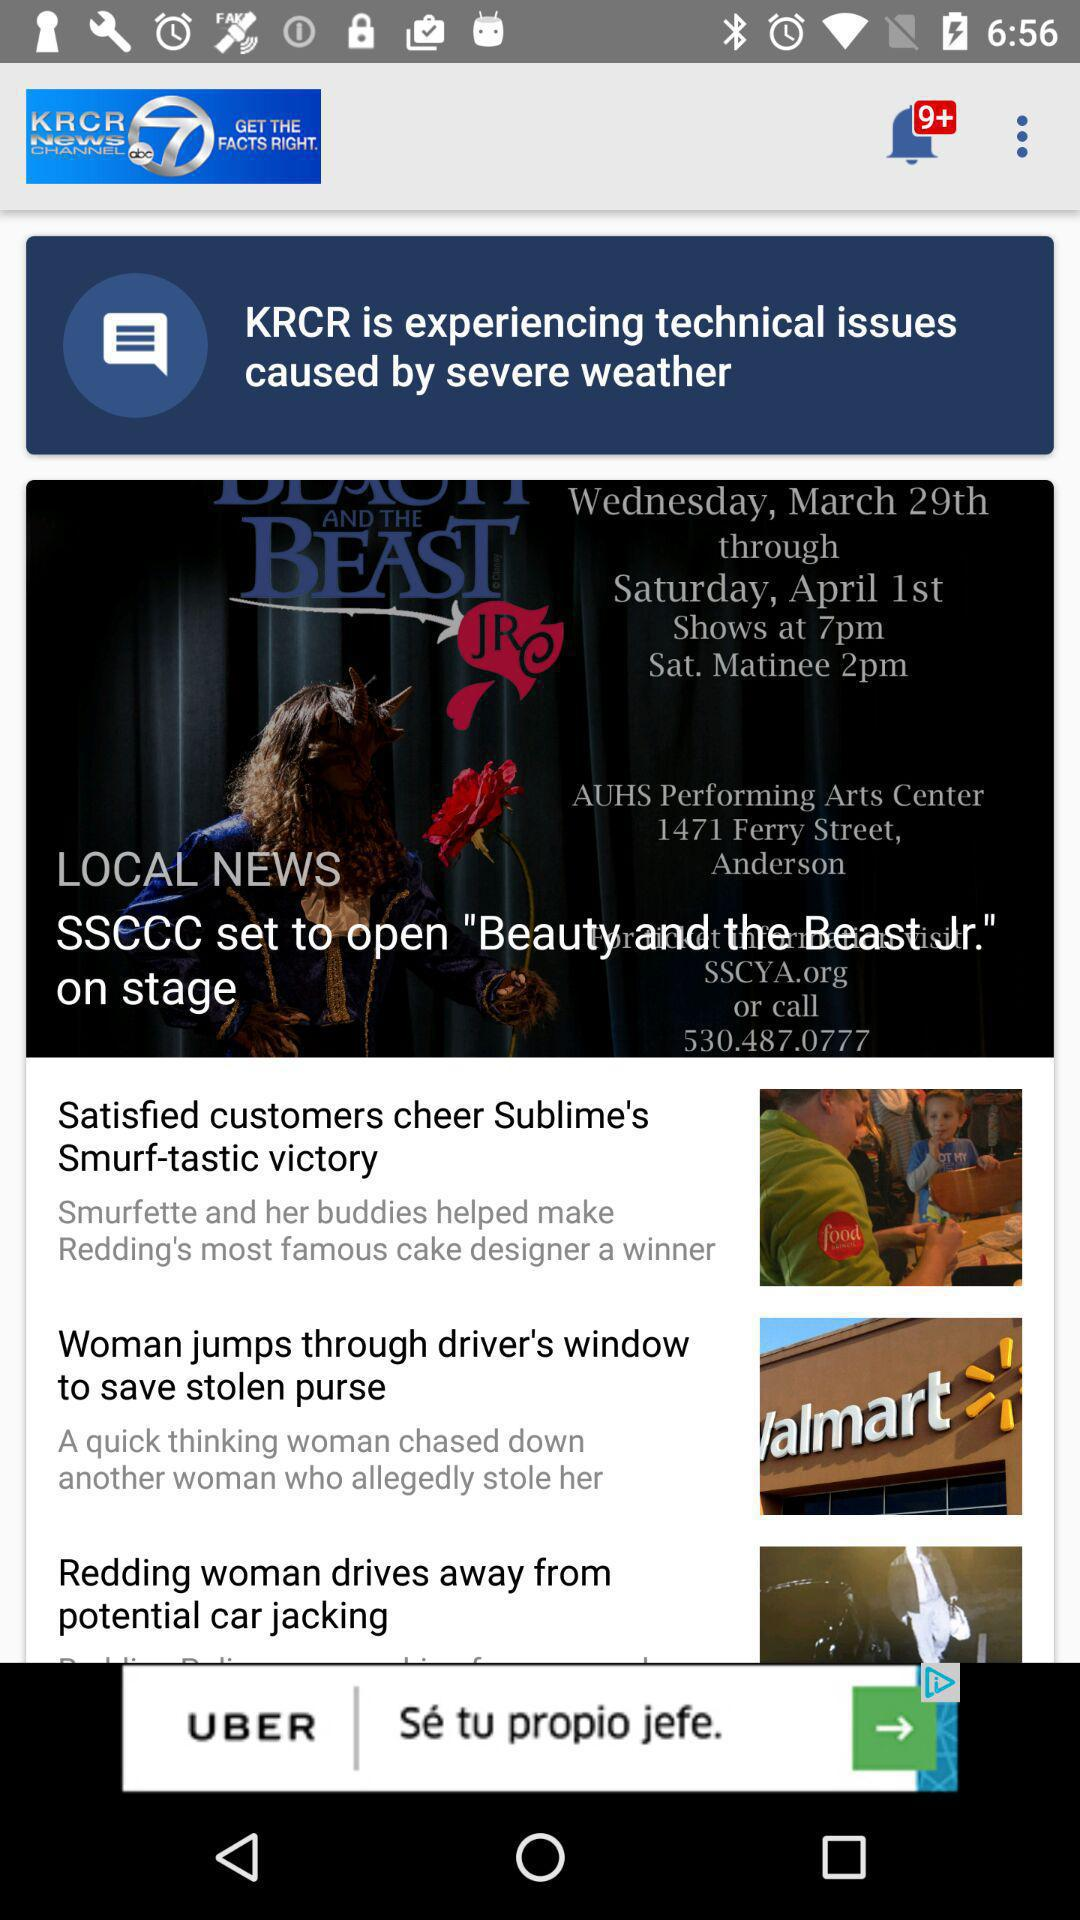What is the local news headline? The local news headline is "SSCCC set to open "Beauty and the Beast Jr." on stage". 